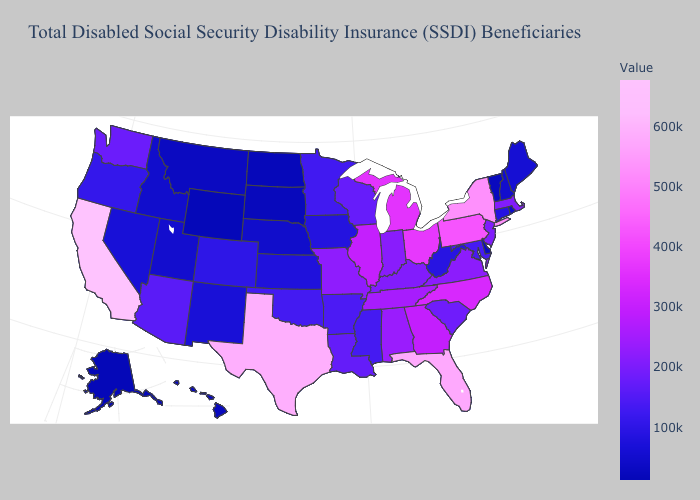Does California have the highest value in the USA?
Write a very short answer. Yes. Does the map have missing data?
Be succinct. No. Does California have the highest value in the West?
Give a very brief answer. Yes. Which states have the lowest value in the MidWest?
Give a very brief answer. North Dakota. 